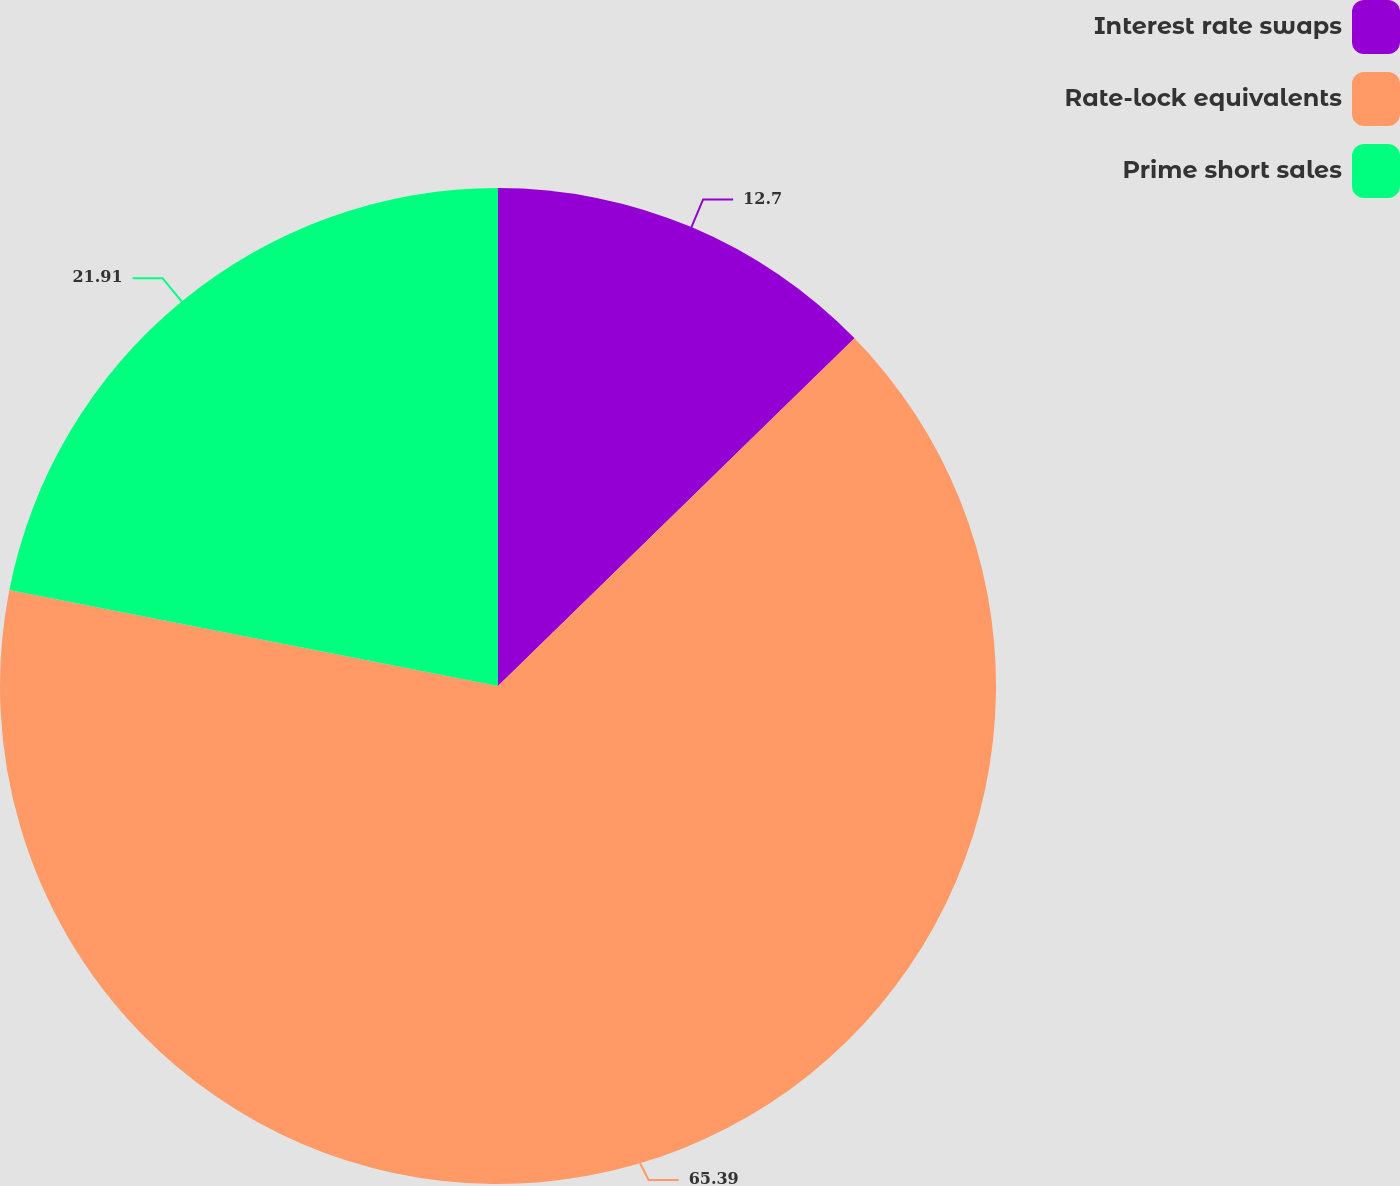<chart> <loc_0><loc_0><loc_500><loc_500><pie_chart><fcel>Interest rate swaps<fcel>Rate-lock equivalents<fcel>Prime short sales<nl><fcel>12.7%<fcel>65.39%<fcel>21.91%<nl></chart> 